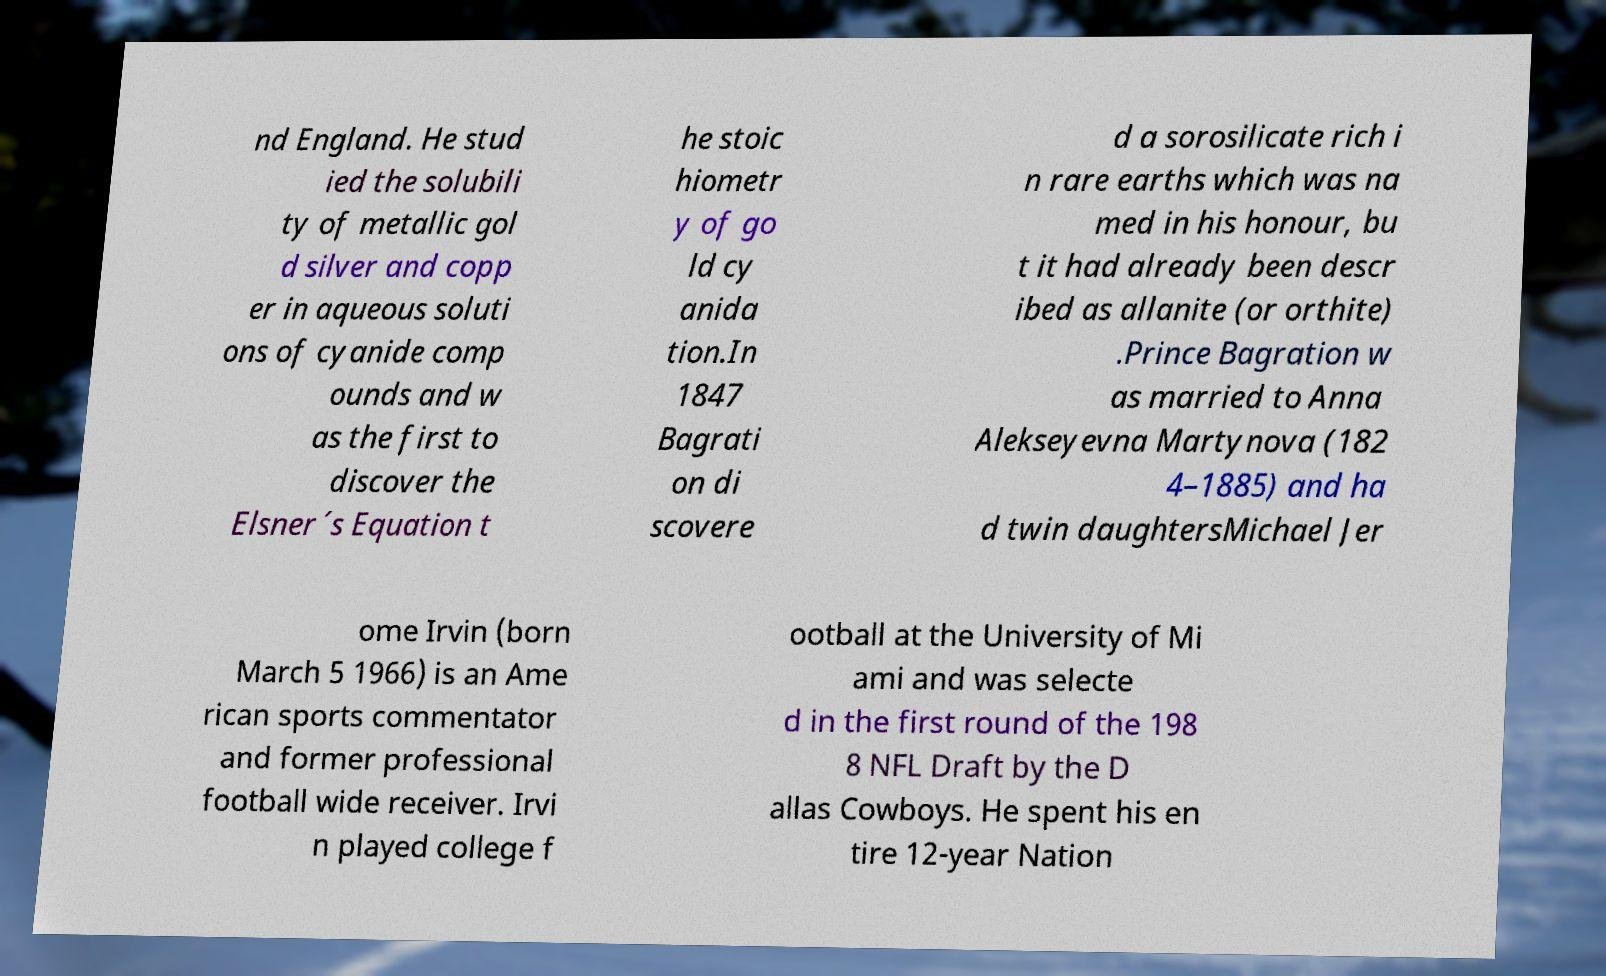What messages or text are displayed in this image? I need them in a readable, typed format. nd England. He stud ied the solubili ty of metallic gol d silver and copp er in aqueous soluti ons of cyanide comp ounds and w as the first to discover the Elsner´s Equation t he stoic hiometr y of go ld cy anida tion.In 1847 Bagrati on di scovere d a sorosilicate rich i n rare earths which was na med in his honour, bu t it had already been descr ibed as allanite (or orthite) .Prince Bagration w as married to Anna Alekseyevna Martynova (182 4–1885) and ha d twin daughtersMichael Jer ome Irvin (born March 5 1966) is an Ame rican sports commentator and former professional football wide receiver. Irvi n played college f ootball at the University of Mi ami and was selecte d in the first round of the 198 8 NFL Draft by the D allas Cowboys. He spent his en tire 12-year Nation 